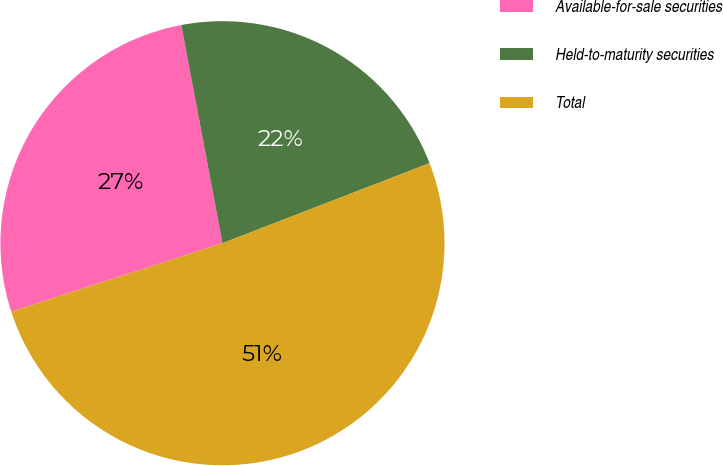Convert chart. <chart><loc_0><loc_0><loc_500><loc_500><pie_chart><fcel>Available-for-sale securities<fcel>Held-to-maturity securities<fcel>Total<nl><fcel>27.02%<fcel>22.1%<fcel>50.88%<nl></chart> 